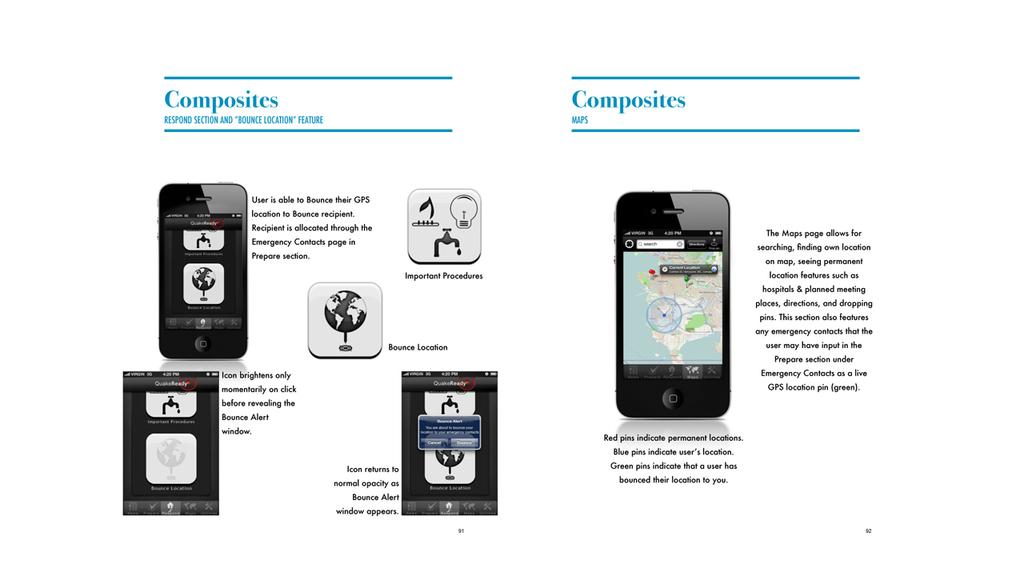<image>
Present a compact description of the photo's key features. A photo of electronic devices says COmposite at the top 